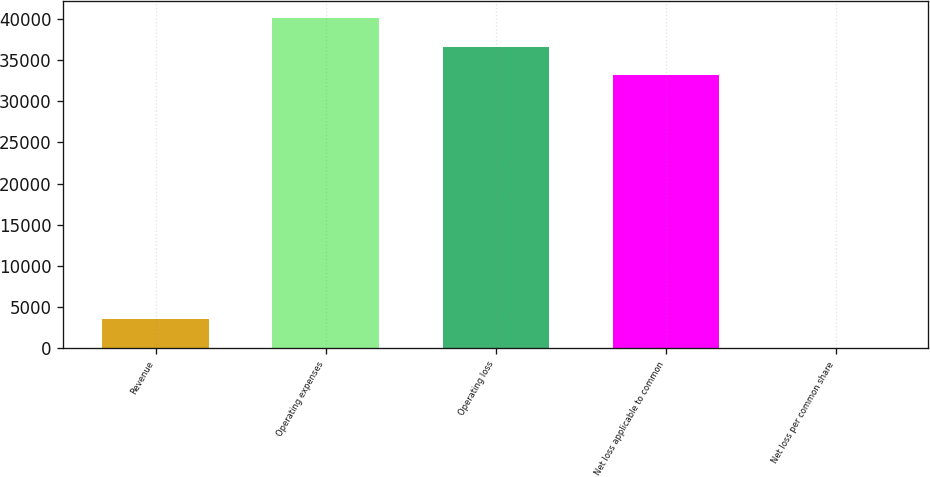Convert chart. <chart><loc_0><loc_0><loc_500><loc_500><bar_chart><fcel>Revenue<fcel>Operating expenses<fcel>Operating loss<fcel>Net loss applicable to common<fcel>Net loss per common share<nl><fcel>3489.35<fcel>40142.6<fcel>36654.3<fcel>33166<fcel>1.06<nl></chart> 